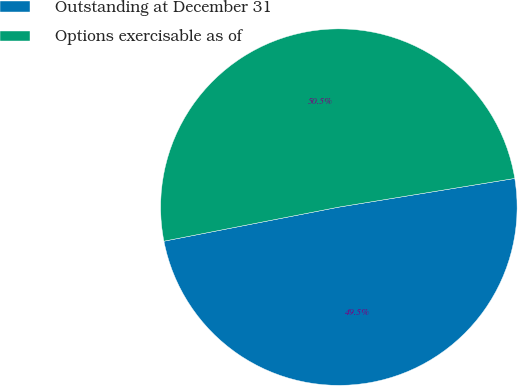Convert chart. <chart><loc_0><loc_0><loc_500><loc_500><pie_chart><fcel>Outstanding at December 31<fcel>Options exercisable as of<nl><fcel>49.51%<fcel>50.49%<nl></chart> 